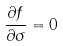<formula> <loc_0><loc_0><loc_500><loc_500>\frac { \partial f } { \partial \sigma } = 0</formula> 